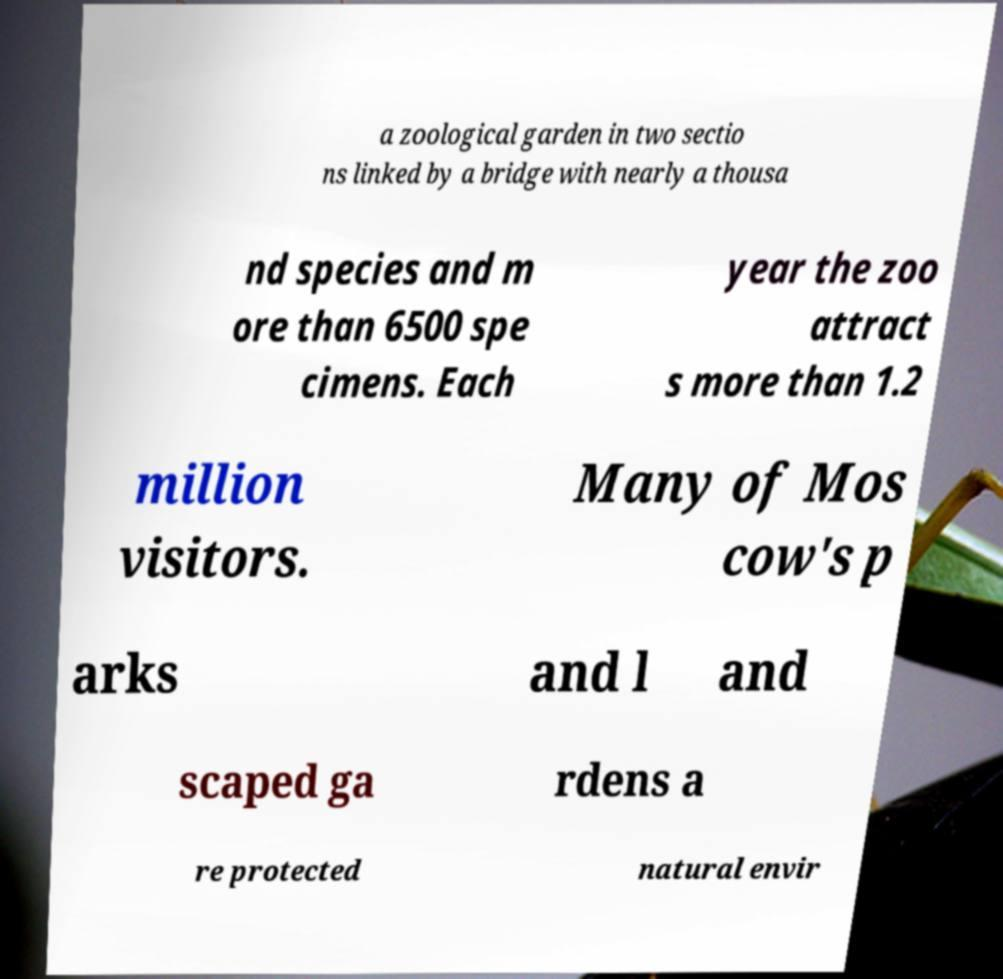Could you assist in decoding the text presented in this image and type it out clearly? a zoological garden in two sectio ns linked by a bridge with nearly a thousa nd species and m ore than 6500 spe cimens. Each year the zoo attract s more than 1.2 million visitors. Many of Mos cow's p arks and l and scaped ga rdens a re protected natural envir 